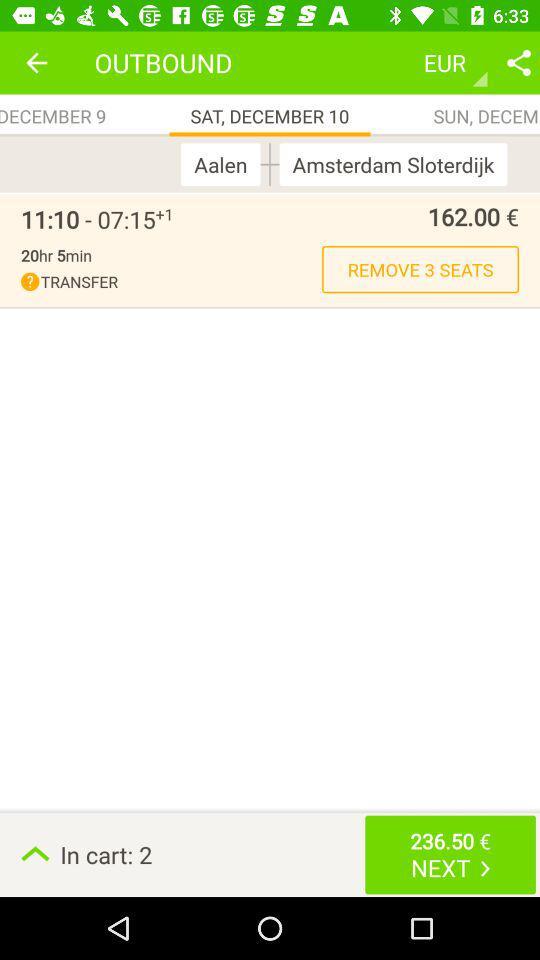What is the total duration? The total duration is 20 hours and 5 minutes. 